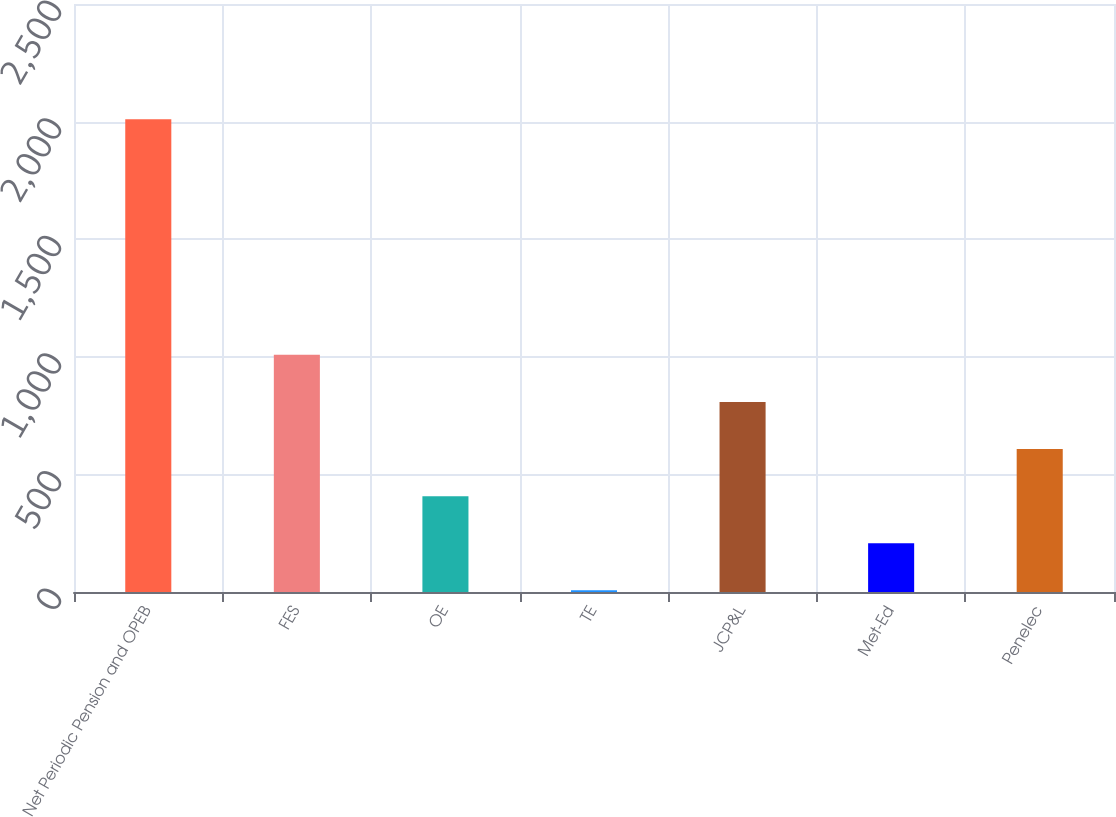<chart> <loc_0><loc_0><loc_500><loc_500><bar_chart><fcel>Net Periodic Pension and OPEB<fcel>FES<fcel>OE<fcel>TE<fcel>JCP&L<fcel>Met-Ed<fcel>Penelec<nl><fcel>2010<fcel>1008.5<fcel>407.6<fcel>7<fcel>808.2<fcel>207.3<fcel>607.9<nl></chart> 